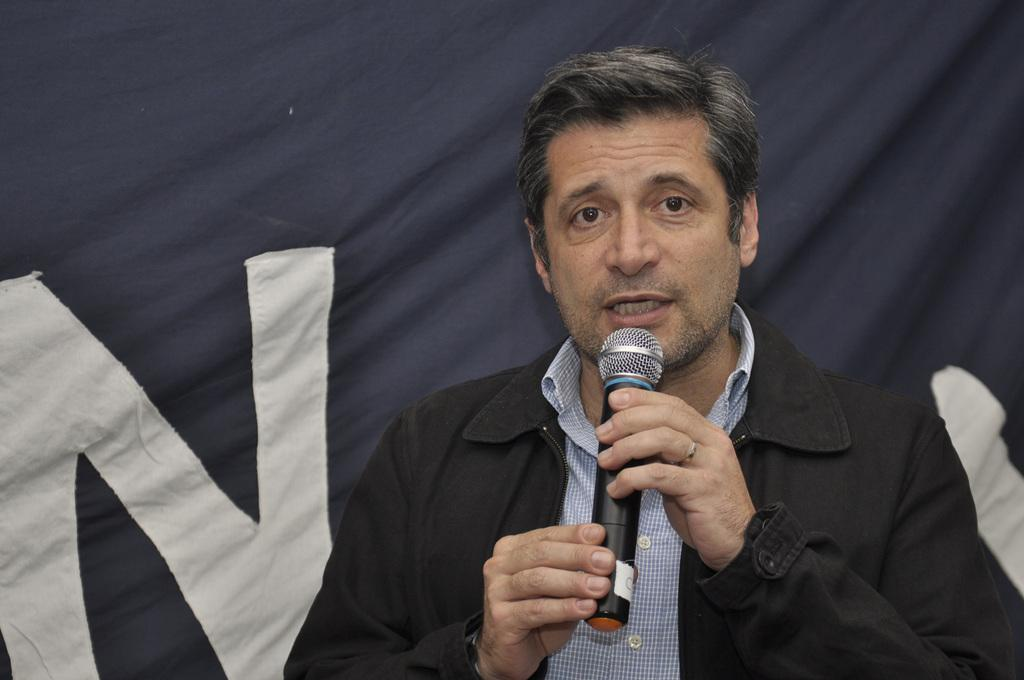What is present in the image? There is a man in the image. What is the man doing in the image? The man is speaking in the image. How is the man speaking in the image? The man is using a microphone to speak in the image. Can you see the man's arm in the image? The provided facts do not mention the man's arm, so it cannot be determined whether it is visible in the image. Is the man skating while speaking in the image? There is no indication in the image that the man is skating; he is using a microphone to speak. What type of animal is present in the image? The provided facts do not mention any animals in the image. 